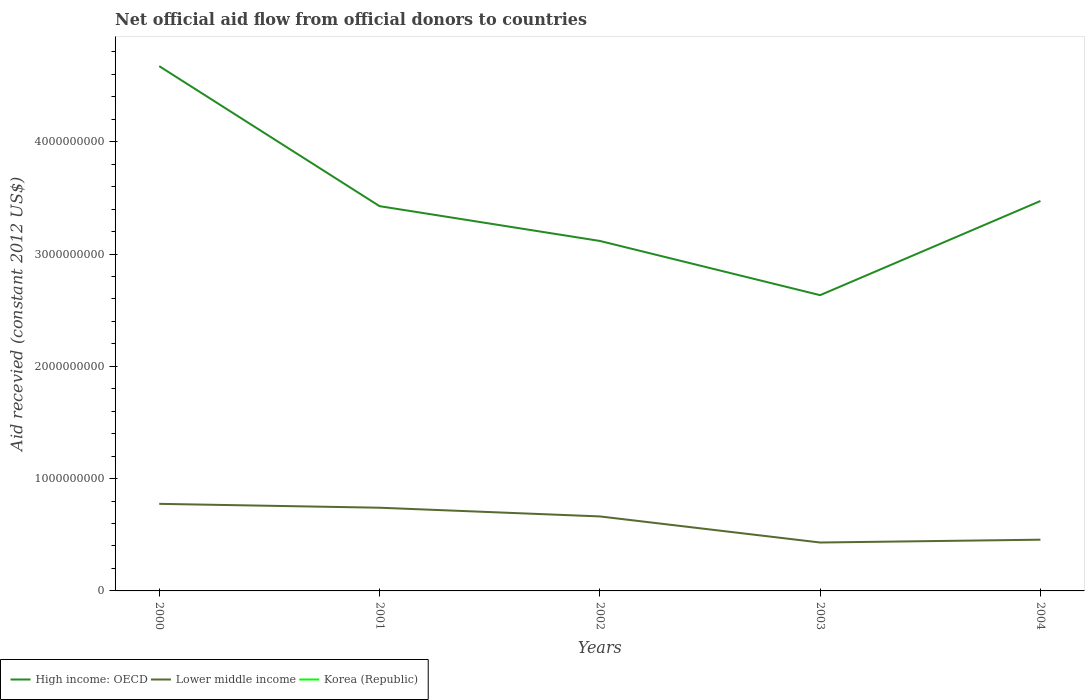Does the line corresponding to High income: OECD intersect with the line corresponding to Korea (Republic)?
Offer a very short reply. No. Across all years, what is the maximum total aid received in Lower middle income?
Offer a very short reply. 4.31e+08. What is the total total aid received in High income: OECD in the graph?
Your answer should be compact. 1.20e+09. What is the difference between the highest and the second highest total aid received in High income: OECD?
Give a very brief answer. 2.04e+09. How many years are there in the graph?
Your answer should be very brief. 5. Does the graph contain any zero values?
Provide a succinct answer. Yes. Does the graph contain grids?
Give a very brief answer. No. Where does the legend appear in the graph?
Keep it short and to the point. Bottom left. How many legend labels are there?
Offer a very short reply. 3. How are the legend labels stacked?
Your answer should be compact. Horizontal. What is the title of the graph?
Your answer should be very brief. Net official aid flow from official donors to countries. What is the label or title of the Y-axis?
Your answer should be compact. Aid recevied (constant 2012 US$). What is the Aid recevied (constant 2012 US$) of High income: OECD in 2000?
Offer a very short reply. 4.67e+09. What is the Aid recevied (constant 2012 US$) of Lower middle income in 2000?
Give a very brief answer. 7.75e+08. What is the Aid recevied (constant 2012 US$) of Korea (Republic) in 2000?
Provide a short and direct response. 0. What is the Aid recevied (constant 2012 US$) in High income: OECD in 2001?
Give a very brief answer. 3.43e+09. What is the Aid recevied (constant 2012 US$) of Lower middle income in 2001?
Make the answer very short. 7.41e+08. What is the Aid recevied (constant 2012 US$) of Korea (Republic) in 2001?
Ensure brevity in your answer.  0. What is the Aid recevied (constant 2012 US$) in High income: OECD in 2002?
Provide a succinct answer. 3.12e+09. What is the Aid recevied (constant 2012 US$) in Lower middle income in 2002?
Keep it short and to the point. 6.63e+08. What is the Aid recevied (constant 2012 US$) in High income: OECD in 2003?
Your response must be concise. 2.63e+09. What is the Aid recevied (constant 2012 US$) in Lower middle income in 2003?
Keep it short and to the point. 4.31e+08. What is the Aid recevied (constant 2012 US$) in Korea (Republic) in 2003?
Ensure brevity in your answer.  0. What is the Aid recevied (constant 2012 US$) of High income: OECD in 2004?
Your answer should be very brief. 3.47e+09. What is the Aid recevied (constant 2012 US$) of Lower middle income in 2004?
Your response must be concise. 4.56e+08. Across all years, what is the maximum Aid recevied (constant 2012 US$) in High income: OECD?
Ensure brevity in your answer.  4.67e+09. Across all years, what is the maximum Aid recevied (constant 2012 US$) in Lower middle income?
Provide a short and direct response. 7.75e+08. Across all years, what is the minimum Aid recevied (constant 2012 US$) of High income: OECD?
Your answer should be compact. 2.63e+09. Across all years, what is the minimum Aid recevied (constant 2012 US$) in Lower middle income?
Your answer should be compact. 4.31e+08. What is the total Aid recevied (constant 2012 US$) of High income: OECD in the graph?
Your answer should be very brief. 1.73e+1. What is the total Aid recevied (constant 2012 US$) in Lower middle income in the graph?
Your answer should be compact. 3.07e+09. What is the total Aid recevied (constant 2012 US$) in Korea (Republic) in the graph?
Provide a short and direct response. 0. What is the difference between the Aid recevied (constant 2012 US$) in High income: OECD in 2000 and that in 2001?
Make the answer very short. 1.25e+09. What is the difference between the Aid recevied (constant 2012 US$) in Lower middle income in 2000 and that in 2001?
Offer a very short reply. 3.46e+07. What is the difference between the Aid recevied (constant 2012 US$) in High income: OECD in 2000 and that in 2002?
Give a very brief answer. 1.56e+09. What is the difference between the Aid recevied (constant 2012 US$) of Lower middle income in 2000 and that in 2002?
Ensure brevity in your answer.  1.12e+08. What is the difference between the Aid recevied (constant 2012 US$) in High income: OECD in 2000 and that in 2003?
Provide a succinct answer. 2.04e+09. What is the difference between the Aid recevied (constant 2012 US$) in Lower middle income in 2000 and that in 2003?
Your answer should be very brief. 3.44e+08. What is the difference between the Aid recevied (constant 2012 US$) of High income: OECD in 2000 and that in 2004?
Offer a terse response. 1.20e+09. What is the difference between the Aid recevied (constant 2012 US$) in Lower middle income in 2000 and that in 2004?
Offer a terse response. 3.19e+08. What is the difference between the Aid recevied (constant 2012 US$) in High income: OECD in 2001 and that in 2002?
Provide a short and direct response. 3.10e+08. What is the difference between the Aid recevied (constant 2012 US$) of Lower middle income in 2001 and that in 2002?
Your response must be concise. 7.75e+07. What is the difference between the Aid recevied (constant 2012 US$) in High income: OECD in 2001 and that in 2003?
Offer a terse response. 7.93e+08. What is the difference between the Aid recevied (constant 2012 US$) of Lower middle income in 2001 and that in 2003?
Your answer should be compact. 3.10e+08. What is the difference between the Aid recevied (constant 2012 US$) of High income: OECD in 2001 and that in 2004?
Offer a very short reply. -4.60e+07. What is the difference between the Aid recevied (constant 2012 US$) of Lower middle income in 2001 and that in 2004?
Offer a terse response. 2.85e+08. What is the difference between the Aid recevied (constant 2012 US$) of High income: OECD in 2002 and that in 2003?
Offer a very short reply. 4.83e+08. What is the difference between the Aid recevied (constant 2012 US$) of Lower middle income in 2002 and that in 2003?
Your answer should be very brief. 2.32e+08. What is the difference between the Aid recevied (constant 2012 US$) in High income: OECD in 2002 and that in 2004?
Make the answer very short. -3.56e+08. What is the difference between the Aid recevied (constant 2012 US$) of Lower middle income in 2002 and that in 2004?
Your response must be concise. 2.07e+08. What is the difference between the Aid recevied (constant 2012 US$) in High income: OECD in 2003 and that in 2004?
Offer a terse response. -8.39e+08. What is the difference between the Aid recevied (constant 2012 US$) of Lower middle income in 2003 and that in 2004?
Ensure brevity in your answer.  -2.51e+07. What is the difference between the Aid recevied (constant 2012 US$) of High income: OECD in 2000 and the Aid recevied (constant 2012 US$) of Lower middle income in 2001?
Provide a short and direct response. 3.93e+09. What is the difference between the Aid recevied (constant 2012 US$) in High income: OECD in 2000 and the Aid recevied (constant 2012 US$) in Lower middle income in 2002?
Provide a succinct answer. 4.01e+09. What is the difference between the Aid recevied (constant 2012 US$) in High income: OECD in 2000 and the Aid recevied (constant 2012 US$) in Lower middle income in 2003?
Provide a short and direct response. 4.24e+09. What is the difference between the Aid recevied (constant 2012 US$) of High income: OECD in 2000 and the Aid recevied (constant 2012 US$) of Lower middle income in 2004?
Ensure brevity in your answer.  4.22e+09. What is the difference between the Aid recevied (constant 2012 US$) in High income: OECD in 2001 and the Aid recevied (constant 2012 US$) in Lower middle income in 2002?
Offer a terse response. 2.76e+09. What is the difference between the Aid recevied (constant 2012 US$) in High income: OECD in 2001 and the Aid recevied (constant 2012 US$) in Lower middle income in 2003?
Make the answer very short. 3.00e+09. What is the difference between the Aid recevied (constant 2012 US$) in High income: OECD in 2001 and the Aid recevied (constant 2012 US$) in Lower middle income in 2004?
Offer a terse response. 2.97e+09. What is the difference between the Aid recevied (constant 2012 US$) in High income: OECD in 2002 and the Aid recevied (constant 2012 US$) in Lower middle income in 2003?
Make the answer very short. 2.69e+09. What is the difference between the Aid recevied (constant 2012 US$) in High income: OECD in 2002 and the Aid recevied (constant 2012 US$) in Lower middle income in 2004?
Offer a terse response. 2.66e+09. What is the difference between the Aid recevied (constant 2012 US$) of High income: OECD in 2003 and the Aid recevied (constant 2012 US$) of Lower middle income in 2004?
Offer a very short reply. 2.18e+09. What is the average Aid recevied (constant 2012 US$) in High income: OECD per year?
Provide a short and direct response. 3.46e+09. What is the average Aid recevied (constant 2012 US$) in Lower middle income per year?
Give a very brief answer. 6.13e+08. What is the average Aid recevied (constant 2012 US$) of Korea (Republic) per year?
Make the answer very short. 0. In the year 2000, what is the difference between the Aid recevied (constant 2012 US$) in High income: OECD and Aid recevied (constant 2012 US$) in Lower middle income?
Provide a short and direct response. 3.90e+09. In the year 2001, what is the difference between the Aid recevied (constant 2012 US$) of High income: OECD and Aid recevied (constant 2012 US$) of Lower middle income?
Keep it short and to the point. 2.69e+09. In the year 2002, what is the difference between the Aid recevied (constant 2012 US$) in High income: OECD and Aid recevied (constant 2012 US$) in Lower middle income?
Keep it short and to the point. 2.45e+09. In the year 2003, what is the difference between the Aid recevied (constant 2012 US$) in High income: OECD and Aid recevied (constant 2012 US$) in Lower middle income?
Keep it short and to the point. 2.20e+09. In the year 2004, what is the difference between the Aid recevied (constant 2012 US$) in High income: OECD and Aid recevied (constant 2012 US$) in Lower middle income?
Offer a very short reply. 3.02e+09. What is the ratio of the Aid recevied (constant 2012 US$) of High income: OECD in 2000 to that in 2001?
Offer a terse response. 1.36. What is the ratio of the Aid recevied (constant 2012 US$) of Lower middle income in 2000 to that in 2001?
Provide a succinct answer. 1.05. What is the ratio of the Aid recevied (constant 2012 US$) in High income: OECD in 2000 to that in 2002?
Your response must be concise. 1.5. What is the ratio of the Aid recevied (constant 2012 US$) of Lower middle income in 2000 to that in 2002?
Give a very brief answer. 1.17. What is the ratio of the Aid recevied (constant 2012 US$) in High income: OECD in 2000 to that in 2003?
Keep it short and to the point. 1.77. What is the ratio of the Aid recevied (constant 2012 US$) in Lower middle income in 2000 to that in 2003?
Your response must be concise. 1.8. What is the ratio of the Aid recevied (constant 2012 US$) in High income: OECD in 2000 to that in 2004?
Offer a very short reply. 1.35. What is the ratio of the Aid recevied (constant 2012 US$) in Lower middle income in 2000 to that in 2004?
Offer a very short reply. 1.7. What is the ratio of the Aid recevied (constant 2012 US$) of High income: OECD in 2001 to that in 2002?
Ensure brevity in your answer.  1.1. What is the ratio of the Aid recevied (constant 2012 US$) in Lower middle income in 2001 to that in 2002?
Provide a succinct answer. 1.12. What is the ratio of the Aid recevied (constant 2012 US$) of High income: OECD in 2001 to that in 2003?
Offer a very short reply. 1.3. What is the ratio of the Aid recevied (constant 2012 US$) in Lower middle income in 2001 to that in 2003?
Your answer should be very brief. 1.72. What is the ratio of the Aid recevied (constant 2012 US$) of High income: OECD in 2001 to that in 2004?
Your response must be concise. 0.99. What is the ratio of the Aid recevied (constant 2012 US$) in Lower middle income in 2001 to that in 2004?
Give a very brief answer. 1.62. What is the ratio of the Aid recevied (constant 2012 US$) in High income: OECD in 2002 to that in 2003?
Your answer should be compact. 1.18. What is the ratio of the Aid recevied (constant 2012 US$) of Lower middle income in 2002 to that in 2003?
Offer a very short reply. 1.54. What is the ratio of the Aid recevied (constant 2012 US$) of High income: OECD in 2002 to that in 2004?
Your answer should be very brief. 0.9. What is the ratio of the Aid recevied (constant 2012 US$) of Lower middle income in 2002 to that in 2004?
Provide a short and direct response. 1.45. What is the ratio of the Aid recevied (constant 2012 US$) of High income: OECD in 2003 to that in 2004?
Provide a succinct answer. 0.76. What is the ratio of the Aid recevied (constant 2012 US$) in Lower middle income in 2003 to that in 2004?
Your answer should be very brief. 0.94. What is the difference between the highest and the second highest Aid recevied (constant 2012 US$) of High income: OECD?
Offer a very short reply. 1.20e+09. What is the difference between the highest and the second highest Aid recevied (constant 2012 US$) in Lower middle income?
Ensure brevity in your answer.  3.46e+07. What is the difference between the highest and the lowest Aid recevied (constant 2012 US$) in High income: OECD?
Make the answer very short. 2.04e+09. What is the difference between the highest and the lowest Aid recevied (constant 2012 US$) in Lower middle income?
Provide a short and direct response. 3.44e+08. 